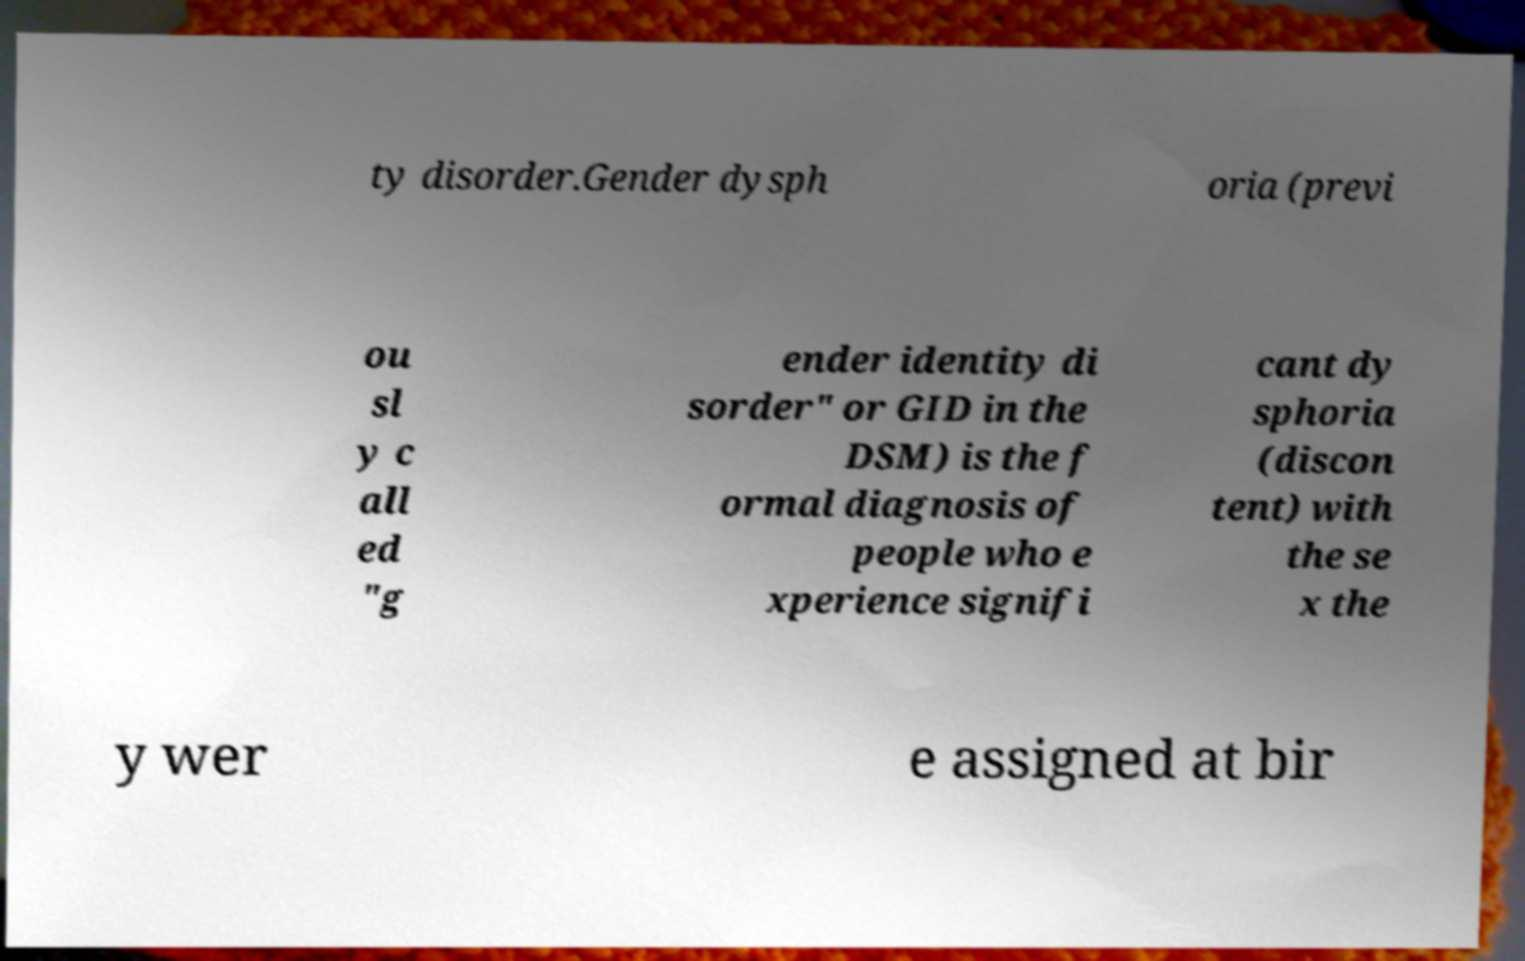Please identify and transcribe the text found in this image. ty disorder.Gender dysph oria (previ ou sl y c all ed "g ender identity di sorder" or GID in the DSM) is the f ormal diagnosis of people who e xperience signifi cant dy sphoria (discon tent) with the se x the y wer e assigned at bir 